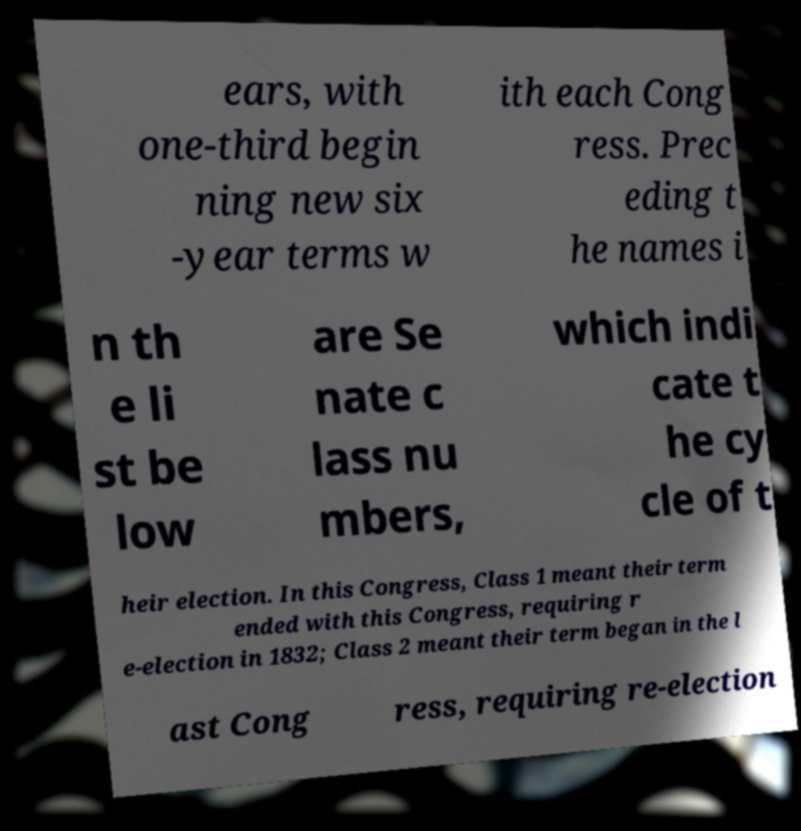There's text embedded in this image that I need extracted. Can you transcribe it verbatim? ears, with one-third begin ning new six -year terms w ith each Cong ress. Prec eding t he names i n th e li st be low are Se nate c lass nu mbers, which indi cate t he cy cle of t heir election. In this Congress, Class 1 meant their term ended with this Congress, requiring r e-election in 1832; Class 2 meant their term began in the l ast Cong ress, requiring re-election 